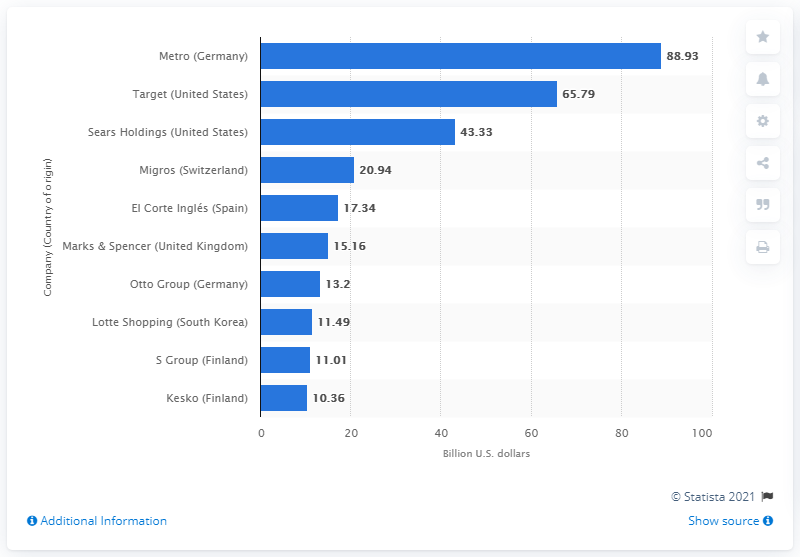Highlight a few significant elements in this photo. In 2010, the sales of Metro amounted to 88.93. 